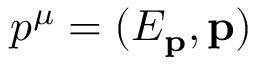Convert formula to latex. <formula><loc_0><loc_0><loc_500><loc_500>p ^ { \mu } = ( E _ { p } , p )</formula> 